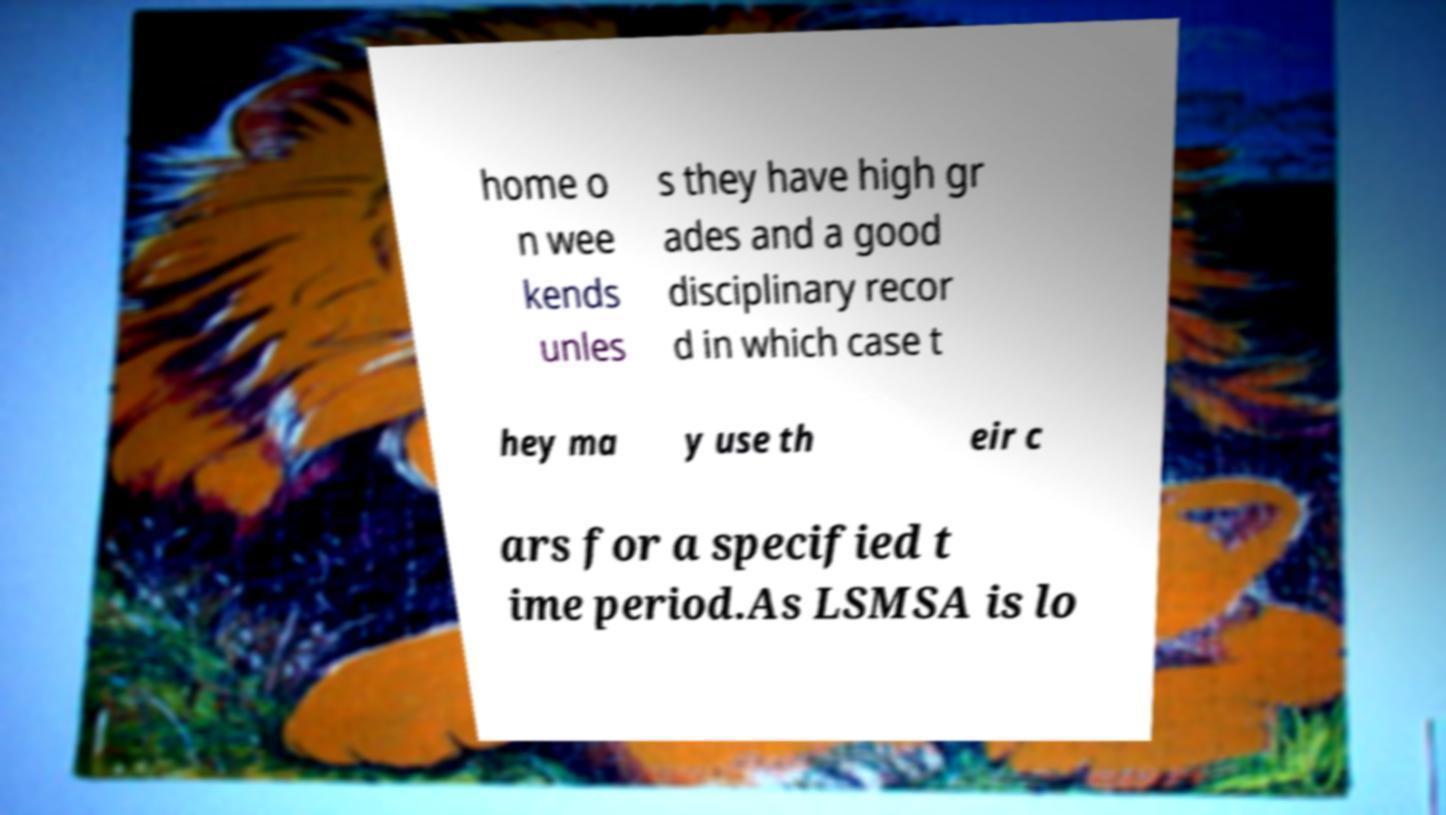Can you accurately transcribe the text from the provided image for me? home o n wee kends unles s they have high gr ades and a good disciplinary recor d in which case t hey ma y use th eir c ars for a specified t ime period.As LSMSA is lo 